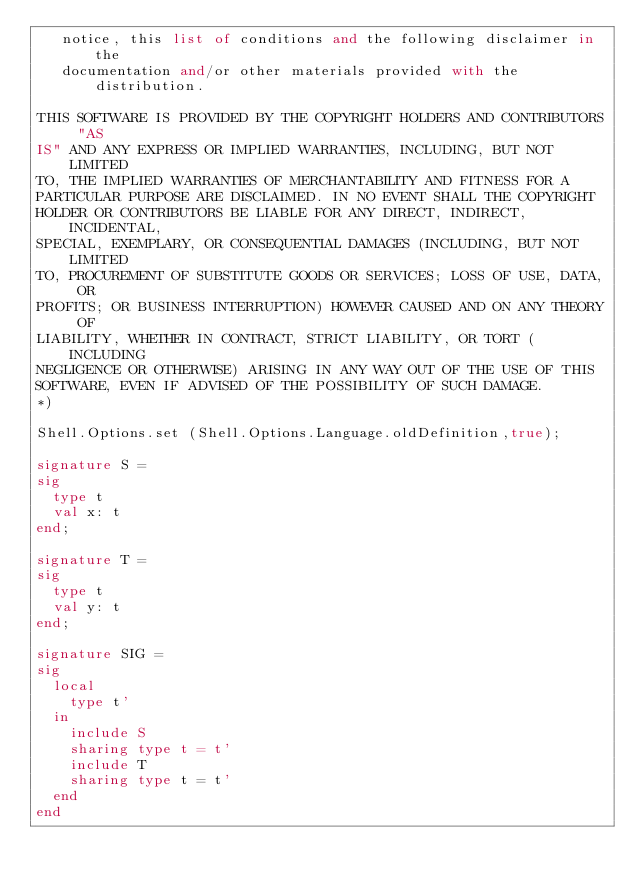Convert code to text. <code><loc_0><loc_0><loc_500><loc_500><_SML_>   notice, this list of conditions and the following disclaimer in the
   documentation and/or other materials provided with the distribution.

THIS SOFTWARE IS PROVIDED BY THE COPYRIGHT HOLDERS AND CONTRIBUTORS "AS
IS" AND ANY EXPRESS OR IMPLIED WARRANTIES, INCLUDING, BUT NOT LIMITED
TO, THE IMPLIED WARRANTIES OF MERCHANTABILITY AND FITNESS FOR A
PARTICULAR PURPOSE ARE DISCLAIMED. IN NO EVENT SHALL THE COPYRIGHT
HOLDER OR CONTRIBUTORS BE LIABLE FOR ANY DIRECT, INDIRECT, INCIDENTAL,
SPECIAL, EXEMPLARY, OR CONSEQUENTIAL DAMAGES (INCLUDING, BUT NOT LIMITED
TO, PROCUREMENT OF SUBSTITUTE GOODS OR SERVICES; LOSS OF USE, DATA, OR
PROFITS; OR BUSINESS INTERRUPTION) HOWEVER CAUSED AND ON ANY THEORY OF
LIABILITY, WHETHER IN CONTRACT, STRICT LIABILITY, OR TORT (INCLUDING
NEGLIGENCE OR OTHERWISE) ARISING IN ANY WAY OUT OF THE USE OF THIS
SOFTWARE, EVEN IF ADVISED OF THE POSSIBILITY OF SUCH DAMAGE.
*)

Shell.Options.set (Shell.Options.Language.oldDefinition,true);

signature S =
sig
  type t
  val x: t
end;

signature T =
sig
  type t
  val y: t
end;

signature SIG = 
sig
  local
    type t'
  in
    include S
    sharing type t = t'
    include T
    sharing type t = t'
  end
end
</code> 